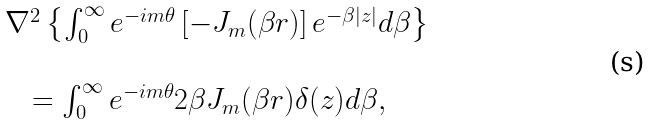Convert formula to latex. <formula><loc_0><loc_0><loc_500><loc_500>\begin{array} { l } \nabla ^ { 2 } \left \{ { \int _ { 0 } ^ { \infty } { e ^ { - i m \theta } \left [ { - J _ { m } ( \beta r ) } \right ] e ^ { - \beta \left | z \right | } d \beta } } \right \} \\ \\ \quad = \int _ { 0 } ^ { \infty } { e ^ { - i m \theta } 2 \beta J _ { m } ( \beta r ) \delta ( z ) d \beta } , \end{array}</formula> 